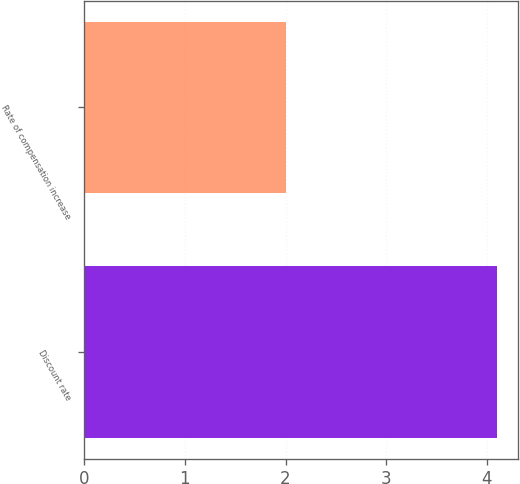Convert chart. <chart><loc_0><loc_0><loc_500><loc_500><bar_chart><fcel>Discount rate<fcel>Rate of compensation increase<nl><fcel>4.1<fcel>2<nl></chart> 